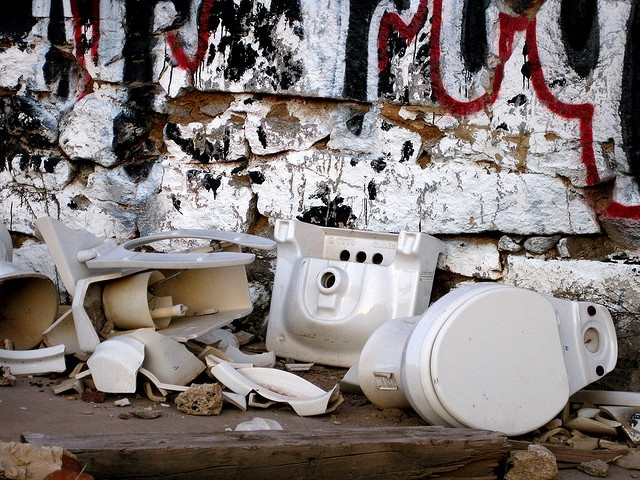Describe the objects in this image and their specific colors. I can see toilet in black, lightgray, darkgray, and gray tones and sink in black, lightgray, darkgray, and gray tones in this image. 